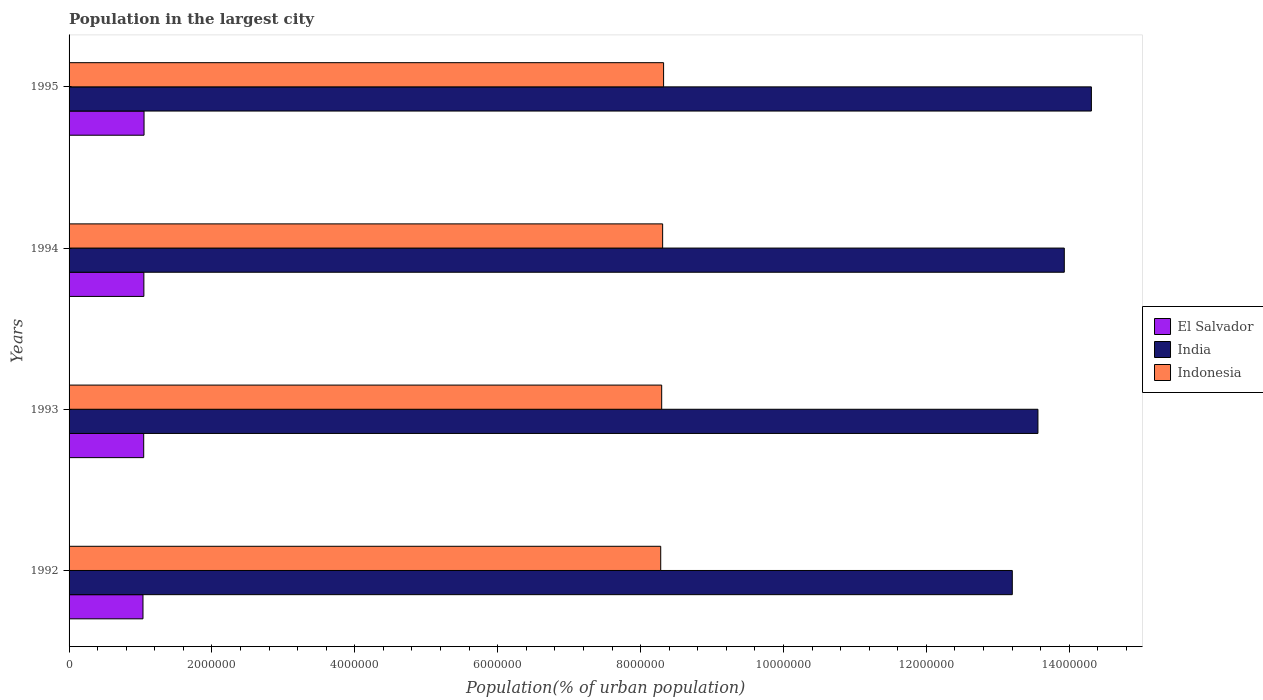How many different coloured bars are there?
Provide a succinct answer. 3. Are the number of bars per tick equal to the number of legend labels?
Offer a very short reply. Yes. Are the number of bars on each tick of the Y-axis equal?
Offer a very short reply. Yes. How many bars are there on the 3rd tick from the top?
Your answer should be compact. 3. How many bars are there on the 1st tick from the bottom?
Make the answer very short. 3. In how many cases, is the number of bars for a given year not equal to the number of legend labels?
Give a very brief answer. 0. What is the population in the largest city in El Salvador in 1992?
Your response must be concise. 1.03e+06. Across all years, what is the maximum population in the largest city in India?
Make the answer very short. 1.43e+07. Across all years, what is the minimum population in the largest city in Indonesia?
Offer a very short reply. 8.28e+06. In which year was the population in the largest city in Indonesia minimum?
Your answer should be very brief. 1992. What is the total population in the largest city in India in the graph?
Your answer should be very brief. 5.50e+07. What is the difference between the population in the largest city in El Salvador in 1992 and that in 1994?
Provide a short and direct response. -1.23e+04. What is the difference between the population in the largest city in El Salvador in 1994 and the population in the largest city in Indonesia in 1995?
Keep it short and to the point. -7.27e+06. What is the average population in the largest city in India per year?
Your response must be concise. 1.38e+07. In the year 1993, what is the difference between the population in the largest city in Indonesia and population in the largest city in India?
Offer a very short reply. -5.27e+06. What is the ratio of the population in the largest city in El Salvador in 1994 to that in 1995?
Keep it short and to the point. 1. Is the difference between the population in the largest city in Indonesia in 1992 and 1994 greater than the difference between the population in the largest city in India in 1992 and 1994?
Offer a very short reply. Yes. What is the difference between the highest and the second highest population in the largest city in El Salvador?
Your answer should be very brief. 2422. What is the difference between the highest and the lowest population in the largest city in India?
Ensure brevity in your answer.  1.11e+06. What does the 1st bar from the bottom in 1995 represents?
Make the answer very short. El Salvador. Is it the case that in every year, the sum of the population in the largest city in Indonesia and population in the largest city in El Salvador is greater than the population in the largest city in India?
Your answer should be compact. No. Are all the bars in the graph horizontal?
Keep it short and to the point. Yes. Where does the legend appear in the graph?
Provide a succinct answer. Center right. How many legend labels are there?
Offer a very short reply. 3. What is the title of the graph?
Give a very brief answer. Population in the largest city. What is the label or title of the X-axis?
Make the answer very short. Population(% of urban population). What is the label or title of the Y-axis?
Offer a terse response. Years. What is the Population(% of urban population) of El Salvador in 1992?
Your answer should be very brief. 1.03e+06. What is the Population(% of urban population) of India in 1992?
Give a very brief answer. 1.32e+07. What is the Population(% of urban population) of Indonesia in 1992?
Your answer should be compact. 8.28e+06. What is the Population(% of urban population) of El Salvador in 1993?
Your answer should be very brief. 1.04e+06. What is the Population(% of urban population) in India in 1993?
Your answer should be compact. 1.36e+07. What is the Population(% of urban population) of Indonesia in 1993?
Make the answer very short. 8.29e+06. What is the Population(% of urban population) of El Salvador in 1994?
Your response must be concise. 1.05e+06. What is the Population(% of urban population) in India in 1994?
Keep it short and to the point. 1.39e+07. What is the Population(% of urban population) in Indonesia in 1994?
Provide a short and direct response. 8.31e+06. What is the Population(% of urban population) in El Salvador in 1995?
Your response must be concise. 1.05e+06. What is the Population(% of urban population) in India in 1995?
Provide a short and direct response. 1.43e+07. What is the Population(% of urban population) in Indonesia in 1995?
Provide a succinct answer. 8.32e+06. Across all years, what is the maximum Population(% of urban population) in El Salvador?
Give a very brief answer. 1.05e+06. Across all years, what is the maximum Population(% of urban population) of India?
Offer a very short reply. 1.43e+07. Across all years, what is the maximum Population(% of urban population) in Indonesia?
Offer a very short reply. 8.32e+06. Across all years, what is the minimum Population(% of urban population) of El Salvador?
Give a very brief answer. 1.03e+06. Across all years, what is the minimum Population(% of urban population) in India?
Provide a short and direct response. 1.32e+07. Across all years, what is the minimum Population(% of urban population) in Indonesia?
Your response must be concise. 8.28e+06. What is the total Population(% of urban population) in El Salvador in the graph?
Offer a very short reply. 4.18e+06. What is the total Population(% of urban population) in India in the graph?
Your answer should be compact. 5.50e+07. What is the total Population(% of urban population) in Indonesia in the graph?
Make the answer very short. 3.32e+07. What is the difference between the Population(% of urban population) of El Salvador in 1992 and that in 1993?
Your answer should be compact. -9927. What is the difference between the Population(% of urban population) of India in 1992 and that in 1993?
Make the answer very short. -3.59e+05. What is the difference between the Population(% of urban population) in Indonesia in 1992 and that in 1993?
Provide a short and direct response. -1.34e+04. What is the difference between the Population(% of urban population) of El Salvador in 1992 and that in 1994?
Give a very brief answer. -1.23e+04. What is the difference between the Population(% of urban population) of India in 1992 and that in 1994?
Offer a very short reply. -7.28e+05. What is the difference between the Population(% of urban population) of Indonesia in 1992 and that in 1994?
Give a very brief answer. -2.68e+04. What is the difference between the Population(% of urban population) of El Salvador in 1992 and that in 1995?
Offer a terse response. -1.48e+04. What is the difference between the Population(% of urban population) in India in 1992 and that in 1995?
Offer a terse response. -1.11e+06. What is the difference between the Population(% of urban population) of Indonesia in 1992 and that in 1995?
Offer a terse response. -4.03e+04. What is the difference between the Population(% of urban population) of El Salvador in 1993 and that in 1994?
Offer a very short reply. -2417. What is the difference between the Population(% of urban population) of India in 1993 and that in 1994?
Make the answer very short. -3.69e+05. What is the difference between the Population(% of urban population) of Indonesia in 1993 and that in 1994?
Keep it short and to the point. -1.34e+04. What is the difference between the Population(% of urban population) of El Salvador in 1993 and that in 1995?
Your answer should be very brief. -4839. What is the difference between the Population(% of urban population) of India in 1993 and that in 1995?
Give a very brief answer. -7.48e+05. What is the difference between the Population(% of urban population) of Indonesia in 1993 and that in 1995?
Make the answer very short. -2.69e+04. What is the difference between the Population(% of urban population) in El Salvador in 1994 and that in 1995?
Ensure brevity in your answer.  -2422. What is the difference between the Population(% of urban population) in India in 1994 and that in 1995?
Keep it short and to the point. -3.79e+05. What is the difference between the Population(% of urban population) in Indonesia in 1994 and that in 1995?
Keep it short and to the point. -1.35e+04. What is the difference between the Population(% of urban population) of El Salvador in 1992 and the Population(% of urban population) of India in 1993?
Give a very brief answer. -1.25e+07. What is the difference between the Population(% of urban population) in El Salvador in 1992 and the Population(% of urban population) in Indonesia in 1993?
Your answer should be compact. -7.26e+06. What is the difference between the Population(% of urban population) of India in 1992 and the Population(% of urban population) of Indonesia in 1993?
Provide a short and direct response. 4.91e+06. What is the difference between the Population(% of urban population) in El Salvador in 1992 and the Population(% of urban population) in India in 1994?
Keep it short and to the point. -1.29e+07. What is the difference between the Population(% of urban population) in El Salvador in 1992 and the Population(% of urban population) in Indonesia in 1994?
Your answer should be compact. -7.27e+06. What is the difference between the Population(% of urban population) in India in 1992 and the Population(% of urban population) in Indonesia in 1994?
Give a very brief answer. 4.89e+06. What is the difference between the Population(% of urban population) of El Salvador in 1992 and the Population(% of urban population) of India in 1995?
Your response must be concise. -1.33e+07. What is the difference between the Population(% of urban population) in El Salvador in 1992 and the Population(% of urban population) in Indonesia in 1995?
Make the answer very short. -7.29e+06. What is the difference between the Population(% of urban population) in India in 1992 and the Population(% of urban population) in Indonesia in 1995?
Make the answer very short. 4.88e+06. What is the difference between the Population(% of urban population) of El Salvador in 1993 and the Population(% of urban population) of India in 1994?
Your answer should be very brief. -1.29e+07. What is the difference between the Population(% of urban population) of El Salvador in 1993 and the Population(% of urban population) of Indonesia in 1994?
Offer a very short reply. -7.26e+06. What is the difference between the Population(% of urban population) of India in 1993 and the Population(% of urban population) of Indonesia in 1994?
Provide a short and direct response. 5.25e+06. What is the difference between the Population(% of urban population) in El Salvador in 1993 and the Population(% of urban population) in India in 1995?
Your answer should be compact. -1.33e+07. What is the difference between the Population(% of urban population) in El Salvador in 1993 and the Population(% of urban population) in Indonesia in 1995?
Keep it short and to the point. -7.28e+06. What is the difference between the Population(% of urban population) of India in 1993 and the Population(% of urban population) of Indonesia in 1995?
Make the answer very short. 5.24e+06. What is the difference between the Population(% of urban population) of El Salvador in 1994 and the Population(% of urban population) of India in 1995?
Your answer should be very brief. -1.33e+07. What is the difference between the Population(% of urban population) in El Salvador in 1994 and the Population(% of urban population) in Indonesia in 1995?
Your response must be concise. -7.27e+06. What is the difference between the Population(% of urban population) in India in 1994 and the Population(% of urban population) in Indonesia in 1995?
Offer a very short reply. 5.61e+06. What is the average Population(% of urban population) of El Salvador per year?
Your answer should be compact. 1.04e+06. What is the average Population(% of urban population) in India per year?
Your answer should be compact. 1.38e+07. What is the average Population(% of urban population) of Indonesia per year?
Offer a very short reply. 8.30e+06. In the year 1992, what is the difference between the Population(% of urban population) in El Salvador and Population(% of urban population) in India?
Make the answer very short. -1.22e+07. In the year 1992, what is the difference between the Population(% of urban population) in El Salvador and Population(% of urban population) in Indonesia?
Ensure brevity in your answer.  -7.25e+06. In the year 1992, what is the difference between the Population(% of urban population) of India and Population(% of urban population) of Indonesia?
Your response must be concise. 4.92e+06. In the year 1993, what is the difference between the Population(% of urban population) in El Salvador and Population(% of urban population) in India?
Make the answer very short. -1.25e+07. In the year 1993, what is the difference between the Population(% of urban population) in El Salvador and Population(% of urban population) in Indonesia?
Give a very brief answer. -7.25e+06. In the year 1993, what is the difference between the Population(% of urban population) in India and Population(% of urban population) in Indonesia?
Offer a terse response. 5.27e+06. In the year 1994, what is the difference between the Population(% of urban population) in El Salvador and Population(% of urban population) in India?
Offer a very short reply. -1.29e+07. In the year 1994, what is the difference between the Population(% of urban population) in El Salvador and Population(% of urban population) in Indonesia?
Keep it short and to the point. -7.26e+06. In the year 1994, what is the difference between the Population(% of urban population) in India and Population(% of urban population) in Indonesia?
Provide a short and direct response. 5.62e+06. In the year 1995, what is the difference between the Population(% of urban population) of El Salvador and Population(% of urban population) of India?
Provide a short and direct response. -1.33e+07. In the year 1995, what is the difference between the Population(% of urban population) in El Salvador and Population(% of urban population) in Indonesia?
Offer a very short reply. -7.27e+06. In the year 1995, what is the difference between the Population(% of urban population) of India and Population(% of urban population) of Indonesia?
Give a very brief answer. 5.99e+06. What is the ratio of the Population(% of urban population) of El Salvador in 1992 to that in 1993?
Your answer should be very brief. 0.99. What is the ratio of the Population(% of urban population) in India in 1992 to that in 1993?
Your answer should be very brief. 0.97. What is the ratio of the Population(% of urban population) of Indonesia in 1992 to that in 1993?
Ensure brevity in your answer.  1. What is the ratio of the Population(% of urban population) in El Salvador in 1992 to that in 1994?
Provide a succinct answer. 0.99. What is the ratio of the Population(% of urban population) in India in 1992 to that in 1994?
Make the answer very short. 0.95. What is the ratio of the Population(% of urban population) in El Salvador in 1992 to that in 1995?
Your answer should be compact. 0.99. What is the ratio of the Population(% of urban population) in India in 1992 to that in 1995?
Your response must be concise. 0.92. What is the ratio of the Population(% of urban population) of El Salvador in 1993 to that in 1994?
Provide a succinct answer. 1. What is the ratio of the Population(% of urban population) in India in 1993 to that in 1994?
Provide a short and direct response. 0.97. What is the ratio of the Population(% of urban population) of Indonesia in 1993 to that in 1994?
Your response must be concise. 1. What is the ratio of the Population(% of urban population) in El Salvador in 1993 to that in 1995?
Provide a short and direct response. 1. What is the ratio of the Population(% of urban population) in India in 1993 to that in 1995?
Your answer should be compact. 0.95. What is the ratio of the Population(% of urban population) in El Salvador in 1994 to that in 1995?
Provide a short and direct response. 1. What is the ratio of the Population(% of urban population) of India in 1994 to that in 1995?
Offer a terse response. 0.97. What is the difference between the highest and the second highest Population(% of urban population) in El Salvador?
Give a very brief answer. 2422. What is the difference between the highest and the second highest Population(% of urban population) in India?
Your answer should be compact. 3.79e+05. What is the difference between the highest and the second highest Population(% of urban population) of Indonesia?
Provide a short and direct response. 1.35e+04. What is the difference between the highest and the lowest Population(% of urban population) of El Salvador?
Offer a very short reply. 1.48e+04. What is the difference between the highest and the lowest Population(% of urban population) in India?
Ensure brevity in your answer.  1.11e+06. What is the difference between the highest and the lowest Population(% of urban population) in Indonesia?
Make the answer very short. 4.03e+04. 